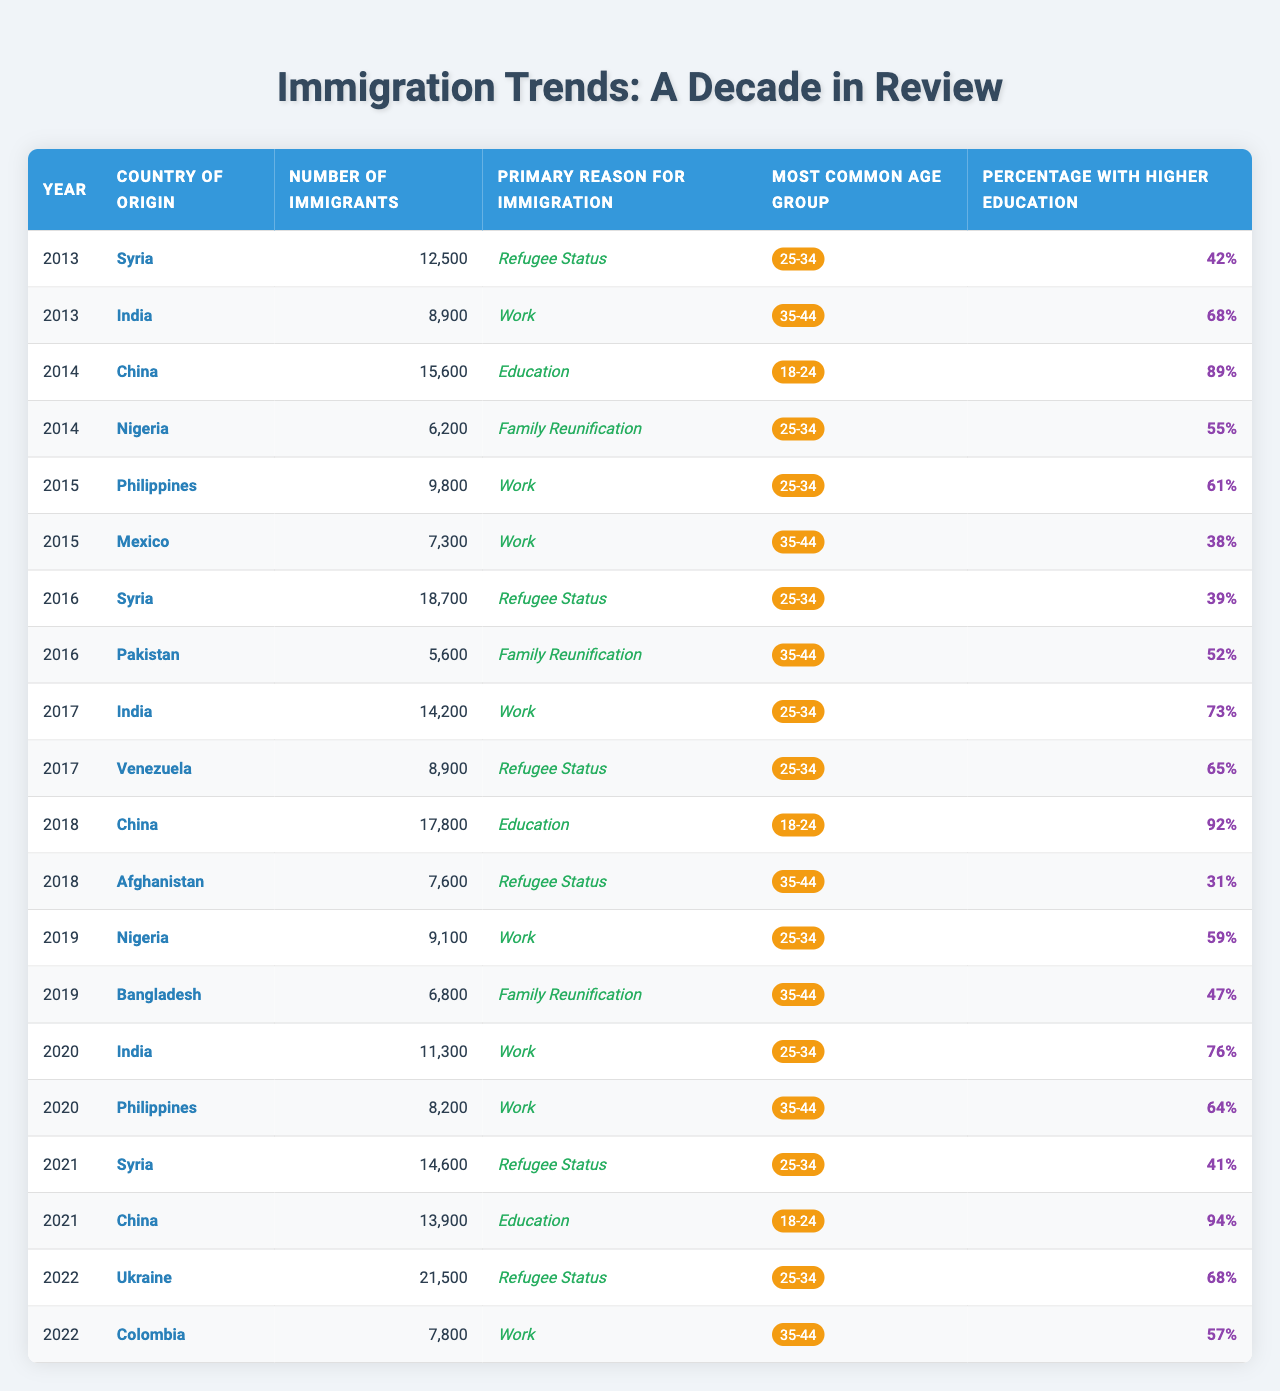What was the primary reason for immigration from Syria in 2016? According to the table, in 2016, the primary reason for immigration from Syria was "Refugee Status."
Answer: Refugee Status Which country had the highest number of immigrants in 2022? In 2022, the country with the highest number of immigrants was Ukraine, with 21,500 immigrants.
Answer: Ukraine What is the percentage of immigrants from India with higher education in 2017? The table shows that in 2017, the percentage of immigrants from India with higher education was 73%.
Answer: 73% What was the average number of immigrants from China from 2014 to 2021? The numbers of immigrants from China during that period were 15,600 (2014), 17,800 (2018), and 13,900 (2021). The average is (15,600 + 17,800 + 13,900) / 3 = 15,433.33, which rounds to 15,433 when expressed as a whole number.
Answer: 15,433 Is it true that the most common age group for immigrants from Nigeria in 2019 was 35-44? Yes, the table indicates that the most common age group for immigrants from Nigeria in 2019 was indeed 25-34. The statement is false.
Answer: False What trends can be observed regarding the primary reason for immigration from 2013 to 2022? Over the years, "Refugee Status" appears frequently, especially around 2016 and 2022, coinciding with crises in Syria and Ukraine. In other years, "Work" and "Education" are also significant.
Answer: Refugee Status is frequent Which country had the lowest number of immigrants in 2015? From the table, it can be seen that in 2015, Mexico had the lowest number of immigrants, with 7,300.
Answer: Mexico How many immigrants from Afghanistan were there in 2018, and what was their primary reason for immigration? In 2018, there were 7,600 immigrants from Afghanistan, and their primary reason for immigration was "Refugee Status."
Answer: 7,600, Refugee Status What is the median percentage of higher education among all countries listed in 2020? The percentages of higher education in 2020 are 76% (India) and 64% (Philippines). The median is the average of these two numbers: (76 + 64) / 2 = 70%.
Answer: 70% What country had the most immigrants in 2014 and what was the reason? In 2014, the most immigrants came from China, with a total of 15,600, and the reason was "Education."
Answer: China, Education 